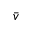<formula> <loc_0><loc_0><loc_500><loc_500>\bar { v }</formula> 